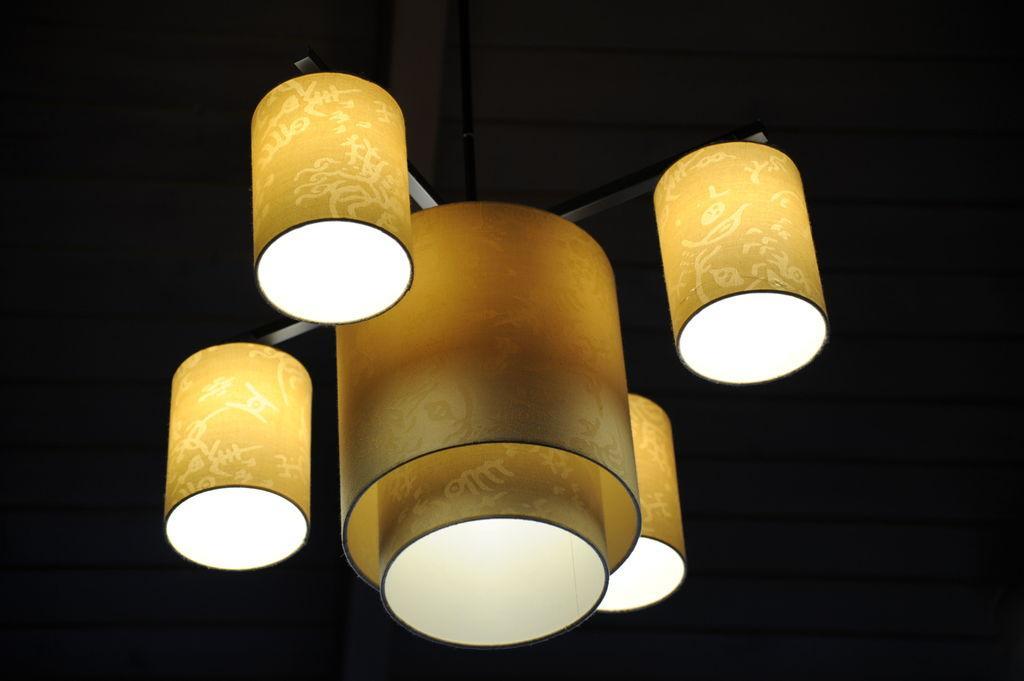How would you summarize this image in a sentence or two? In this image I can see few lights and I can see dark background. 